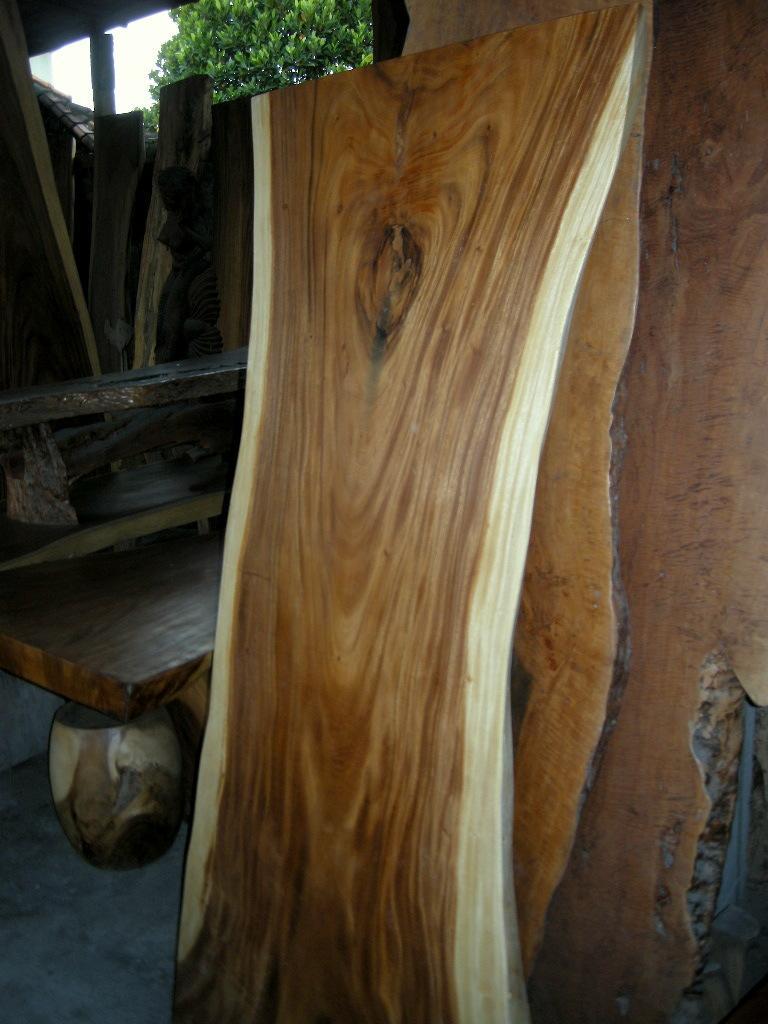In one or two sentences, can you explain what this image depicts? In the picture I can see some wooden planks are placed in one place, behind we can see tree. 